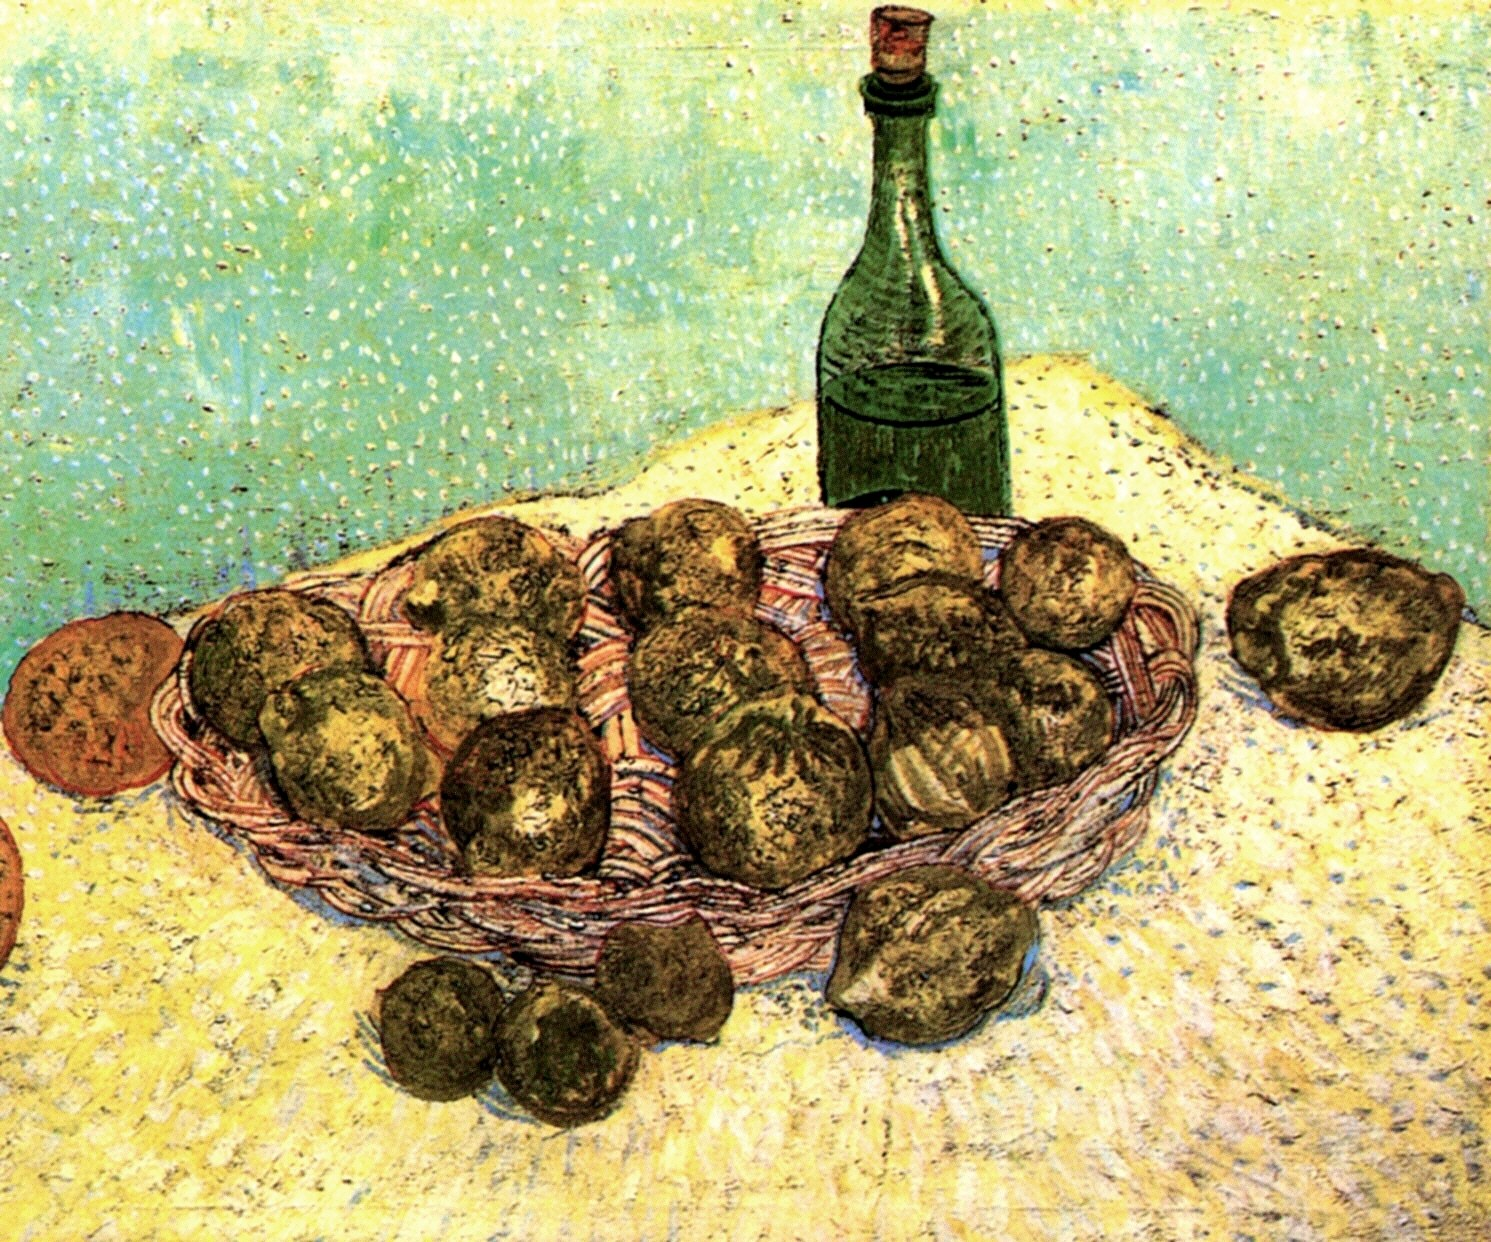Can you explain the significance of the color choices in this painting? Certainly! The artist has chosen a palette that highlights contrasts and vibrancy, which is characteristic of the post-impressionist style. The bright yellow of the tablecloth brings a sense of warmth and light, emphasizing the earthy tones of the potatoes. The green bottle adds a complimentary contrast, which is visually striking against the softer background and enriches the overall composition. These color choices enhance the painting's emotional appeal, suggesting themes of abundance and nature. 